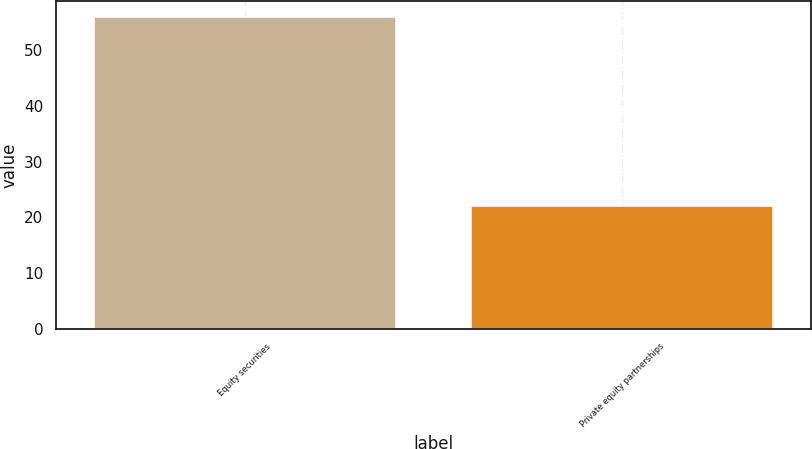Convert chart to OTSL. <chart><loc_0><loc_0><loc_500><loc_500><bar_chart><fcel>Equity securities<fcel>Private equity partnerships<nl><fcel>56<fcel>22<nl></chart> 